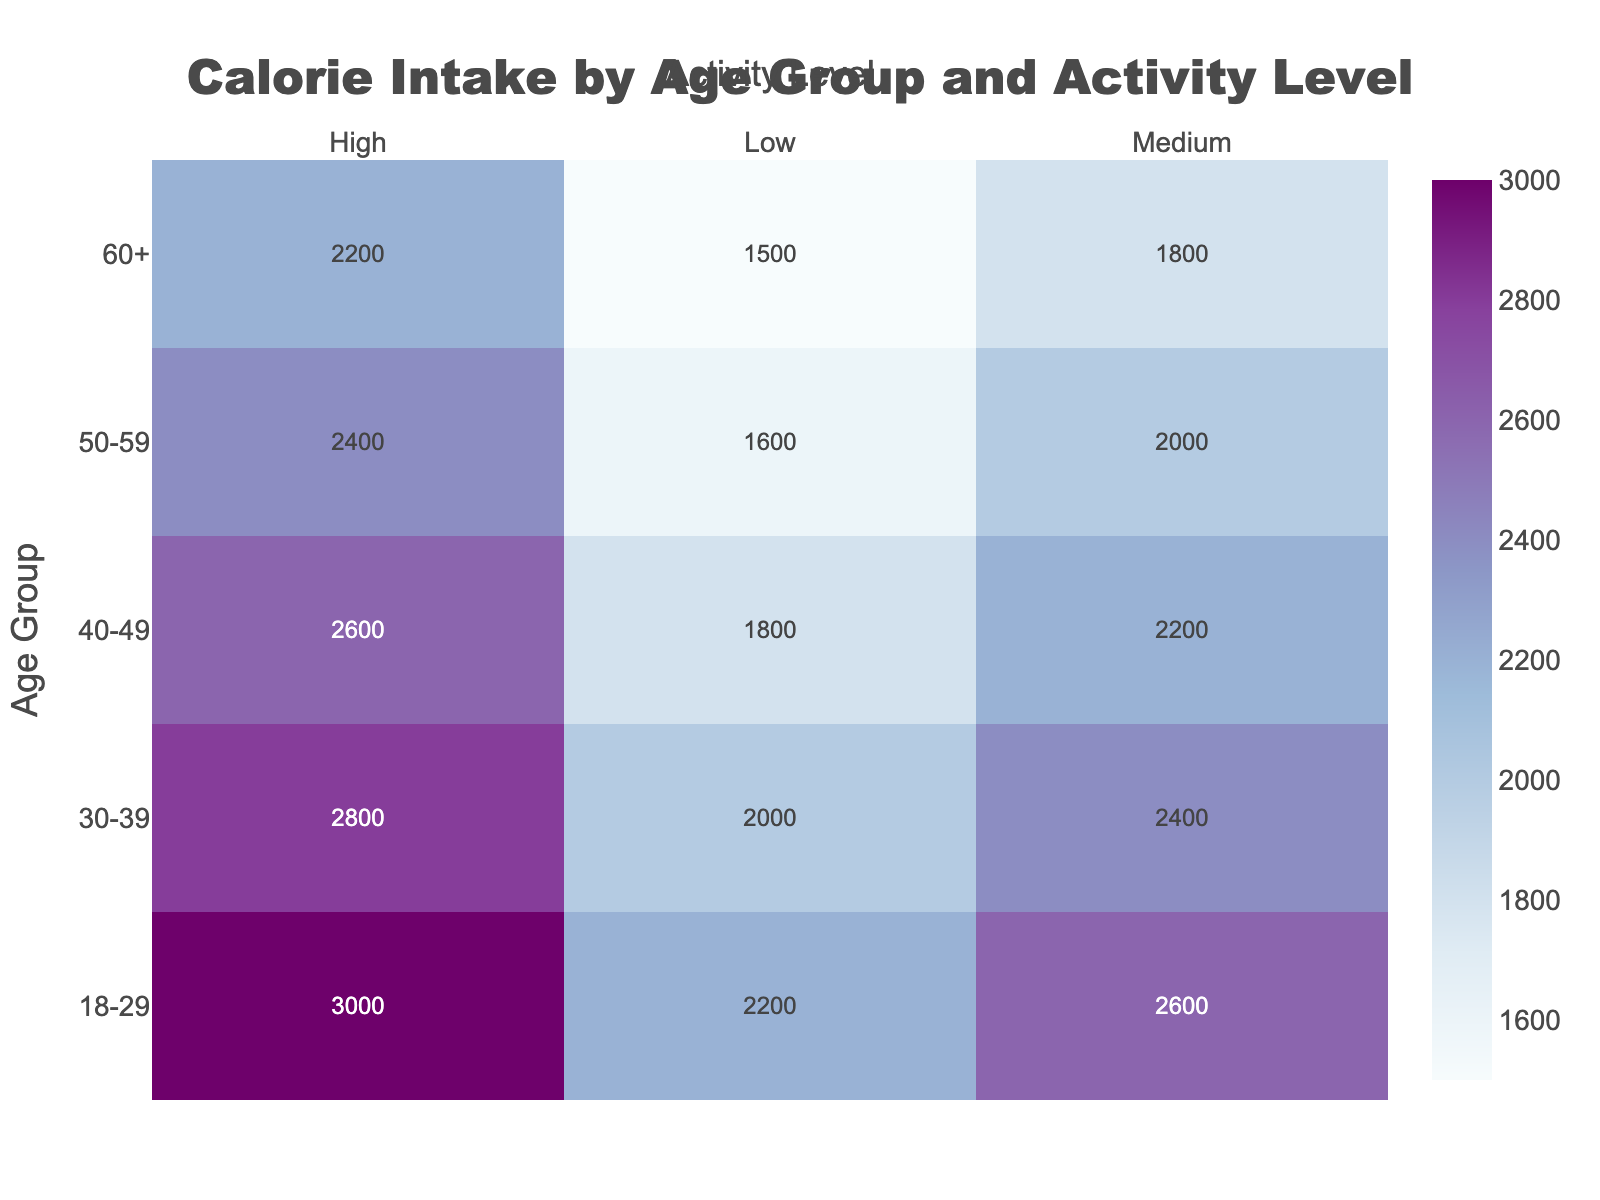What is the title of the heatmap? The title is usually displayed at the top of the heatmap and provides an overview of what the plot represents.
Answer: Calorie Intake by Age Group and Activity Level Which age group has the highest calorie intake at a high activity level? Look for the highest value in the 'High' activity level column and identify the corresponding age group. The highest value is 3000 in the '18-29' age group.
Answer: 18-29 Which activity level and age group combination has the lowest calorie intake? Find the smallest value in the entire heatmap, which is 1500 in the 'Low' activity level column for the '60+' age group.
Answer: Low activity level, 60+ age group What is the difference in calorie intake between the '30-39' and '50-59' age groups at a medium activity level? Subtract the calorie value for the '50-59' group (2000) from the '30-39' group (2400) under the 'Medium' activity level.
Answer: 400 Which age group shows the most significant increase in calorie intake from low to high activity levels? Calculate the difference in calories for each age group from low to high activity levels and identify the maximum change. For '18-29', it's 3000 - 2200 = 800; for '30-39', it's 2800 - 2000 = 800; for '40-49', it's 2600 - 1800 = 800; for '50-59', it's 2400 - 1600 = 800; for '60+', it's 2200 - 1500 = 700.
Answer: 18-29, 30-39, 40-49, 50-59 What are the calorie intake values for the '40-49' age group across all activity levels? Locate the '40-49' age group row and list the values of calories for 'Low', 'Medium', and 'High' activity levels. These values are 1800, 2200, and 2600 respectively.
Answer: 1800, 2200, 2600 How much more calories does the '18-29' age group with high activity need compared to the '60+' age group with low activity? Subtract the '60+' age group's low activity calorie value (1500) from the '18-29' age group's high activity calorie value (3000).
Answer: 1500 Which age group's calorie intake pattern shows the smallest relative difference between medium and high activity levels? Calculate the percentage increase from medium to high activity level for each age group and find the smallest percentage increase. For '18-29', it's (3000-2600)/2600 = 15.38%; for '30-39', it's (2800-2400)/2400 = 16.67%; for '40-49', it's (2600-2200)/2200 = 18.18%; for '50-59', it's (2400-2000)/2000 = 20%; for '60+', it's (2200-1800)/1800 = 22.22%.
Answer: 18-29 In which age group does the calorie intake for medium activity level align closely with the caloric intake of another age group's low activity level? Compare the calorie intake values in the 'Medium' activity level column with the 'Low' activity level column and find any similar values. The '18-29' Medium (2600) is close to the '30-39' High (2800).
Answer: 18-29, 30-39 